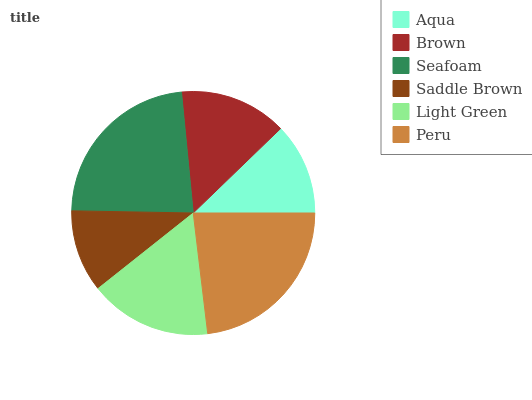Is Saddle Brown the minimum?
Answer yes or no. Yes. Is Seafoam the maximum?
Answer yes or no. Yes. Is Brown the minimum?
Answer yes or no. No. Is Brown the maximum?
Answer yes or no. No. Is Brown greater than Aqua?
Answer yes or no. Yes. Is Aqua less than Brown?
Answer yes or no. Yes. Is Aqua greater than Brown?
Answer yes or no. No. Is Brown less than Aqua?
Answer yes or no. No. Is Light Green the high median?
Answer yes or no. Yes. Is Brown the low median?
Answer yes or no. Yes. Is Seafoam the high median?
Answer yes or no. No. Is Light Green the low median?
Answer yes or no. No. 